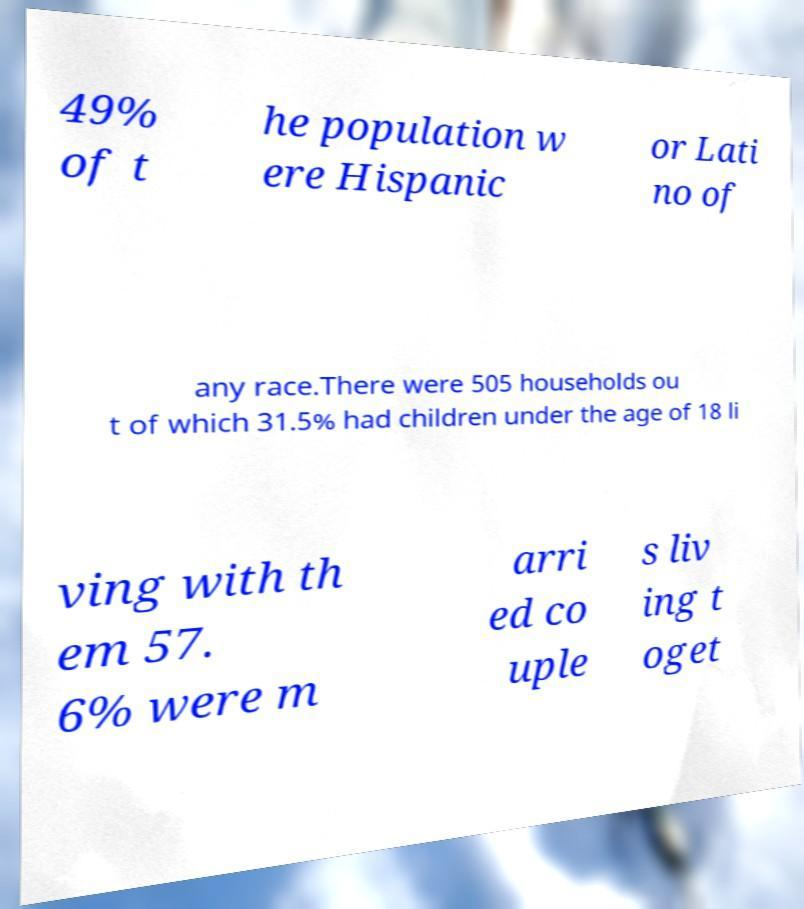Can you accurately transcribe the text from the provided image for me? 49% of t he population w ere Hispanic or Lati no of any race.There were 505 households ou t of which 31.5% had children under the age of 18 li ving with th em 57. 6% were m arri ed co uple s liv ing t oget 